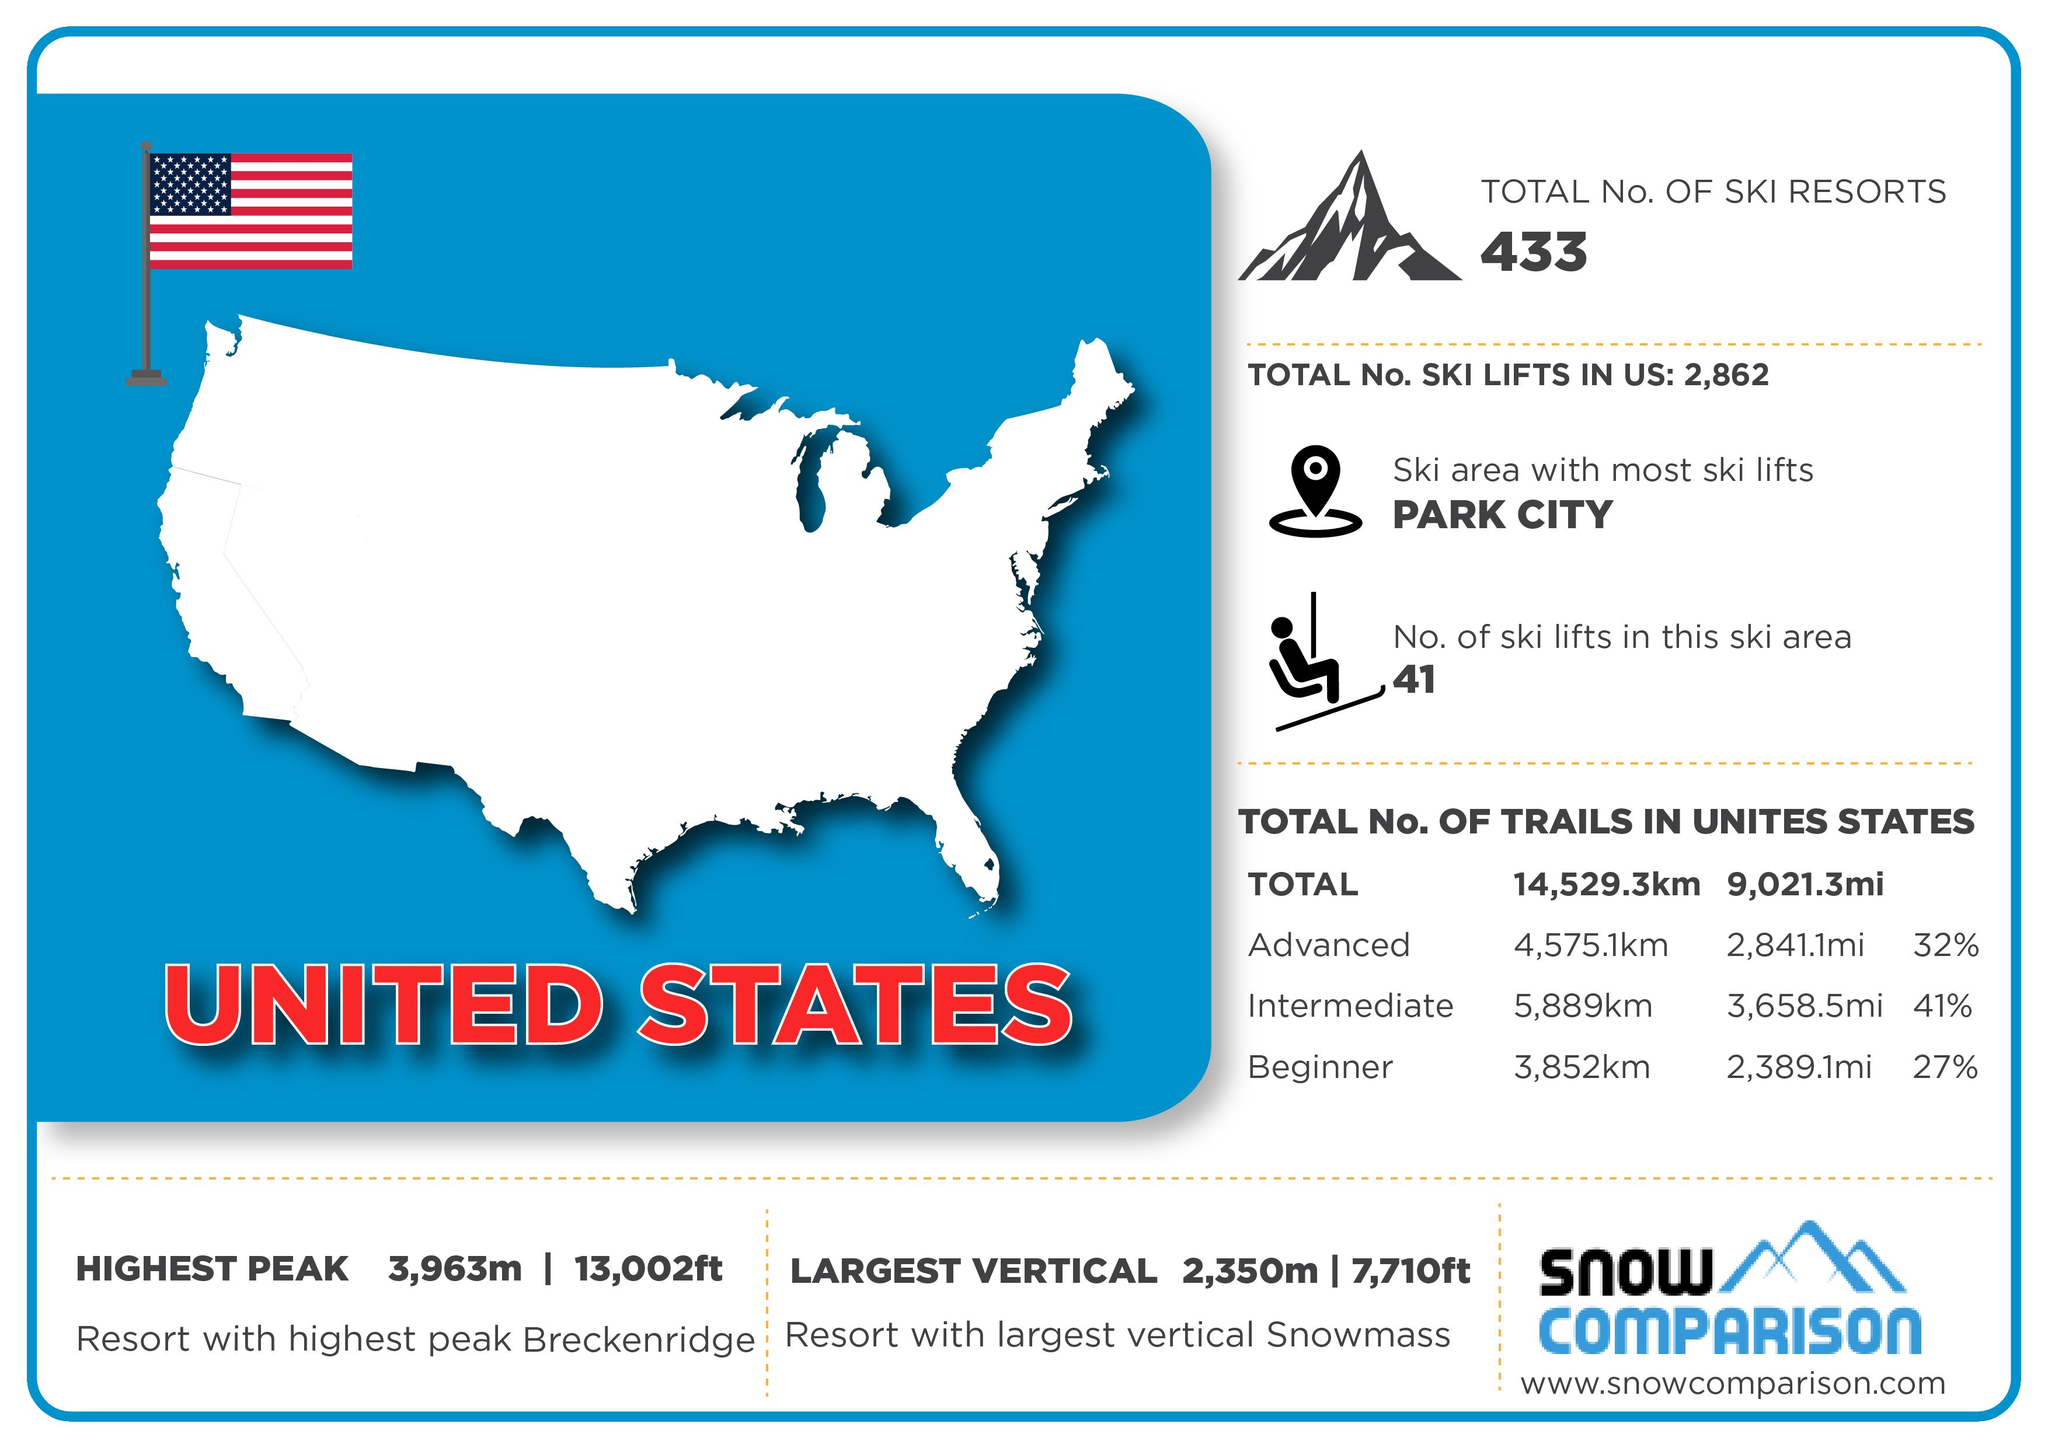Outline some significant characteristics in this image. It is definitively known that 100% of the trails in the US are classified as Advanced, Intermediate, or Beginner. The trail that is considered to be the longest is advanced, intermediate, or beginner. Intermediate. The intermediate trail is significantly longer than the advanced trail, measuring 1,314 km in length. The difference in length between advanced and beginner trails in miles is 452 miles. According to the given information, the intermediate trail is approximately 2037 kilometers in length, while the beginner trail is significantly shorter, with a length of approximately 1020 kilometers. 